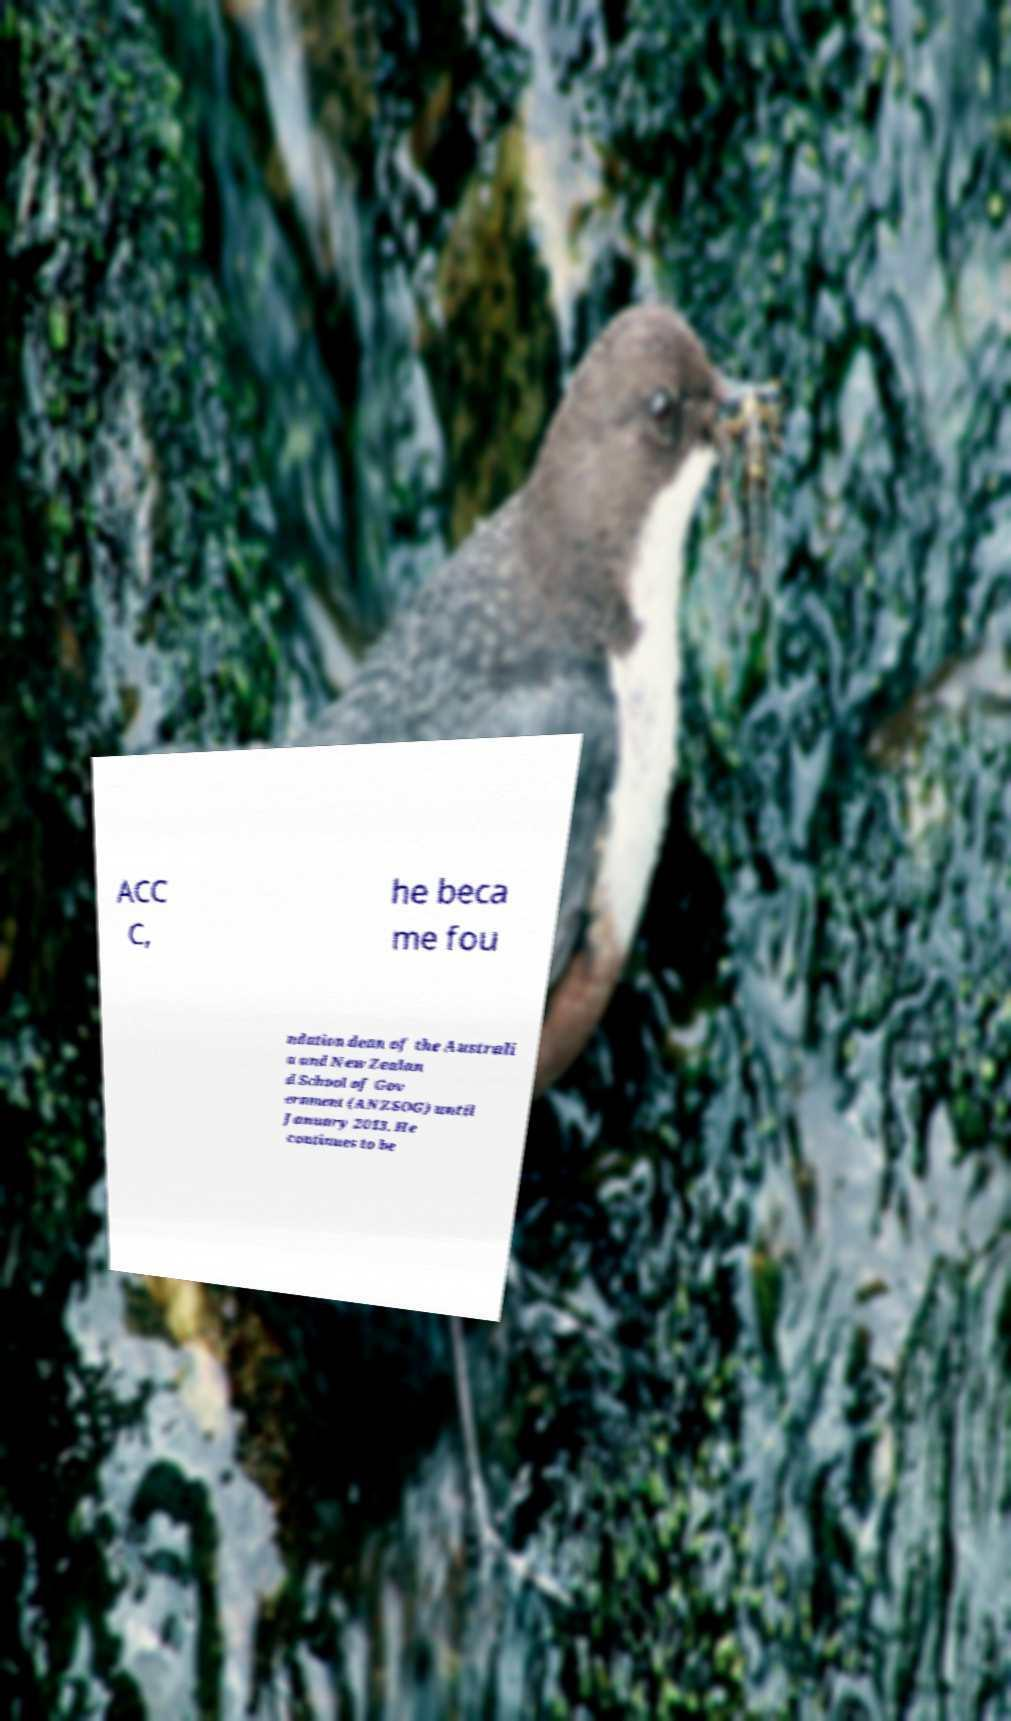Please identify and transcribe the text found in this image. ACC C, he beca me fou ndation dean of the Australi a and New Zealan d School of Gov ernment (ANZSOG) until January 2013. He continues to be 